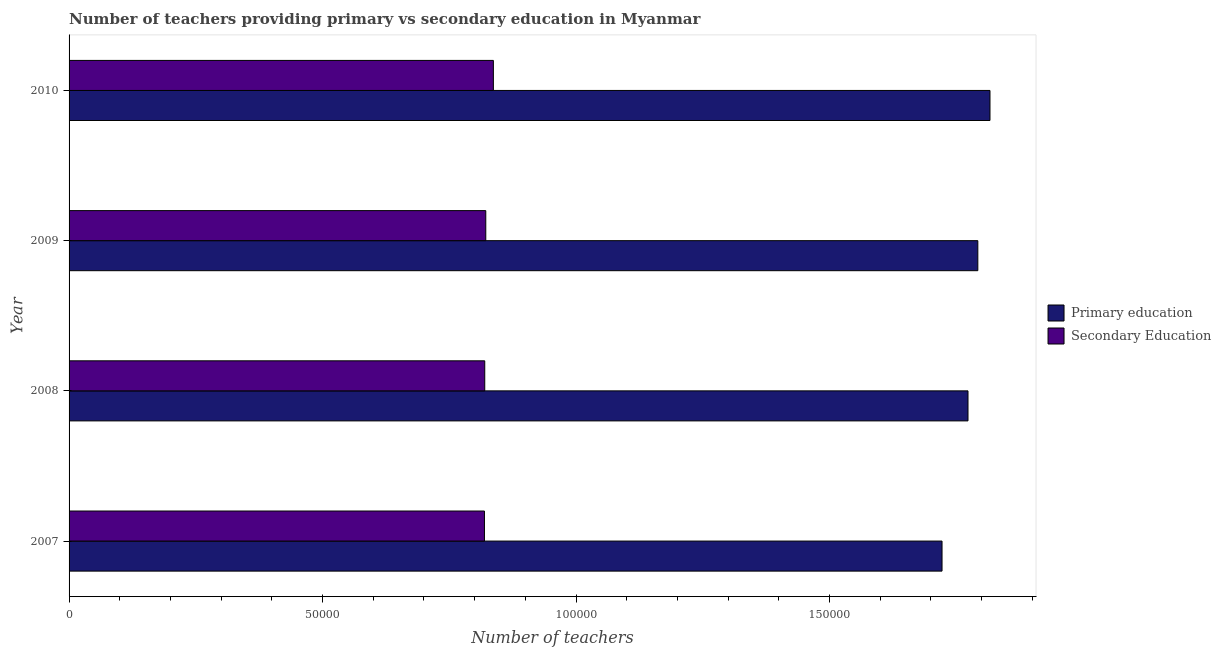How many different coloured bars are there?
Give a very brief answer. 2. How many groups of bars are there?
Ensure brevity in your answer.  4. Are the number of bars on each tick of the Y-axis equal?
Ensure brevity in your answer.  Yes. In how many cases, is the number of bars for a given year not equal to the number of legend labels?
Offer a very short reply. 0. What is the number of primary teachers in 2007?
Your response must be concise. 1.72e+05. Across all years, what is the maximum number of primary teachers?
Ensure brevity in your answer.  1.82e+05. Across all years, what is the minimum number of primary teachers?
Provide a succinct answer. 1.72e+05. In which year was the number of primary teachers minimum?
Give a very brief answer. 2007. What is the total number of primary teachers in the graph?
Ensure brevity in your answer.  7.10e+05. What is the difference between the number of secondary teachers in 2009 and that in 2010?
Provide a succinct answer. -1499. What is the difference between the number of secondary teachers in 2009 and the number of primary teachers in 2010?
Offer a very short reply. -9.95e+04. What is the average number of secondary teachers per year?
Your answer should be compact. 8.25e+04. In the year 2008, what is the difference between the number of secondary teachers and number of primary teachers?
Your response must be concise. -9.53e+04. Is the number of primary teachers in 2007 less than that in 2009?
Make the answer very short. Yes. Is the difference between the number of primary teachers in 2008 and 2010 greater than the difference between the number of secondary teachers in 2008 and 2010?
Offer a terse response. No. What is the difference between the highest and the second highest number of primary teachers?
Give a very brief answer. 2398. What is the difference between the highest and the lowest number of primary teachers?
Ensure brevity in your answer.  9457. What does the 1st bar from the bottom in 2009 represents?
Offer a terse response. Primary education. How many bars are there?
Offer a terse response. 8. Does the graph contain any zero values?
Your answer should be compact. No. What is the title of the graph?
Your answer should be very brief. Number of teachers providing primary vs secondary education in Myanmar. Does "Official creditors" appear as one of the legend labels in the graph?
Keep it short and to the point. No. What is the label or title of the X-axis?
Give a very brief answer. Number of teachers. What is the Number of teachers of Primary education in 2007?
Offer a very short reply. 1.72e+05. What is the Number of teachers of Secondary Education in 2007?
Make the answer very short. 8.19e+04. What is the Number of teachers in Primary education in 2008?
Keep it short and to the point. 1.77e+05. What is the Number of teachers of Secondary Education in 2008?
Your answer should be very brief. 8.20e+04. What is the Number of teachers in Primary education in 2009?
Make the answer very short. 1.79e+05. What is the Number of teachers in Secondary Education in 2009?
Provide a succinct answer. 8.22e+04. What is the Number of teachers in Primary education in 2010?
Your response must be concise. 1.82e+05. What is the Number of teachers of Secondary Education in 2010?
Your answer should be very brief. 8.37e+04. Across all years, what is the maximum Number of teachers in Primary education?
Make the answer very short. 1.82e+05. Across all years, what is the maximum Number of teachers in Secondary Education?
Make the answer very short. 8.37e+04. Across all years, what is the minimum Number of teachers in Primary education?
Make the answer very short. 1.72e+05. Across all years, what is the minimum Number of teachers in Secondary Education?
Your answer should be compact. 8.19e+04. What is the total Number of teachers in Primary education in the graph?
Give a very brief answer. 7.10e+05. What is the total Number of teachers in Secondary Education in the graph?
Your answer should be compact. 3.30e+05. What is the difference between the Number of teachers in Primary education in 2007 and that in 2008?
Give a very brief answer. -5122. What is the difference between the Number of teachers of Secondary Education in 2007 and that in 2008?
Provide a short and direct response. -58. What is the difference between the Number of teachers of Primary education in 2007 and that in 2009?
Your answer should be very brief. -7059. What is the difference between the Number of teachers of Secondary Education in 2007 and that in 2009?
Your answer should be compact. -261. What is the difference between the Number of teachers of Primary education in 2007 and that in 2010?
Make the answer very short. -9457. What is the difference between the Number of teachers of Secondary Education in 2007 and that in 2010?
Your answer should be very brief. -1760. What is the difference between the Number of teachers in Primary education in 2008 and that in 2009?
Your response must be concise. -1937. What is the difference between the Number of teachers of Secondary Education in 2008 and that in 2009?
Offer a terse response. -203. What is the difference between the Number of teachers in Primary education in 2008 and that in 2010?
Offer a terse response. -4335. What is the difference between the Number of teachers of Secondary Education in 2008 and that in 2010?
Make the answer very short. -1702. What is the difference between the Number of teachers in Primary education in 2009 and that in 2010?
Provide a succinct answer. -2398. What is the difference between the Number of teachers in Secondary Education in 2009 and that in 2010?
Give a very brief answer. -1499. What is the difference between the Number of teachers in Primary education in 2007 and the Number of teachers in Secondary Education in 2008?
Your answer should be compact. 9.02e+04. What is the difference between the Number of teachers of Primary education in 2007 and the Number of teachers of Secondary Education in 2009?
Offer a very short reply. 9.00e+04. What is the difference between the Number of teachers in Primary education in 2007 and the Number of teachers in Secondary Education in 2010?
Your response must be concise. 8.85e+04. What is the difference between the Number of teachers of Primary education in 2008 and the Number of teachers of Secondary Education in 2009?
Keep it short and to the point. 9.51e+04. What is the difference between the Number of teachers in Primary education in 2008 and the Number of teachers in Secondary Education in 2010?
Offer a very short reply. 9.36e+04. What is the difference between the Number of teachers in Primary education in 2009 and the Number of teachers in Secondary Education in 2010?
Offer a terse response. 9.56e+04. What is the average Number of teachers of Primary education per year?
Your answer should be compact. 1.78e+05. What is the average Number of teachers of Secondary Education per year?
Keep it short and to the point. 8.25e+04. In the year 2007, what is the difference between the Number of teachers in Primary education and Number of teachers in Secondary Education?
Give a very brief answer. 9.03e+04. In the year 2008, what is the difference between the Number of teachers in Primary education and Number of teachers in Secondary Education?
Offer a very short reply. 9.53e+04. In the year 2009, what is the difference between the Number of teachers in Primary education and Number of teachers in Secondary Education?
Give a very brief answer. 9.71e+04. In the year 2010, what is the difference between the Number of teachers of Primary education and Number of teachers of Secondary Education?
Ensure brevity in your answer.  9.80e+04. What is the ratio of the Number of teachers in Primary education in 2007 to that in 2008?
Give a very brief answer. 0.97. What is the ratio of the Number of teachers in Secondary Education in 2007 to that in 2008?
Offer a terse response. 1. What is the ratio of the Number of teachers in Primary education in 2007 to that in 2009?
Give a very brief answer. 0.96. What is the ratio of the Number of teachers in Primary education in 2007 to that in 2010?
Keep it short and to the point. 0.95. What is the ratio of the Number of teachers of Primary education in 2008 to that in 2009?
Keep it short and to the point. 0.99. What is the ratio of the Number of teachers in Secondary Education in 2008 to that in 2009?
Provide a short and direct response. 1. What is the ratio of the Number of teachers in Primary education in 2008 to that in 2010?
Provide a succinct answer. 0.98. What is the ratio of the Number of teachers in Secondary Education in 2008 to that in 2010?
Provide a short and direct response. 0.98. What is the ratio of the Number of teachers in Secondary Education in 2009 to that in 2010?
Provide a succinct answer. 0.98. What is the difference between the highest and the second highest Number of teachers of Primary education?
Make the answer very short. 2398. What is the difference between the highest and the second highest Number of teachers in Secondary Education?
Give a very brief answer. 1499. What is the difference between the highest and the lowest Number of teachers in Primary education?
Your answer should be compact. 9457. What is the difference between the highest and the lowest Number of teachers in Secondary Education?
Keep it short and to the point. 1760. 